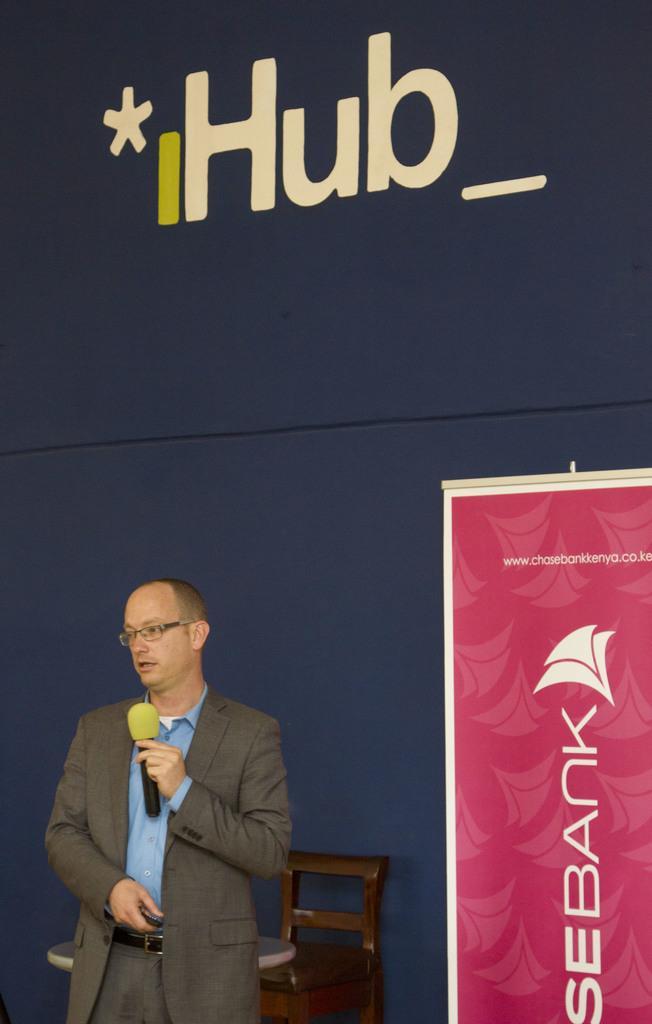Can you describe this image briefly? In this image, we can see man holding mic in his hand and in the background, there is a banner and we can see a chair and a table. 